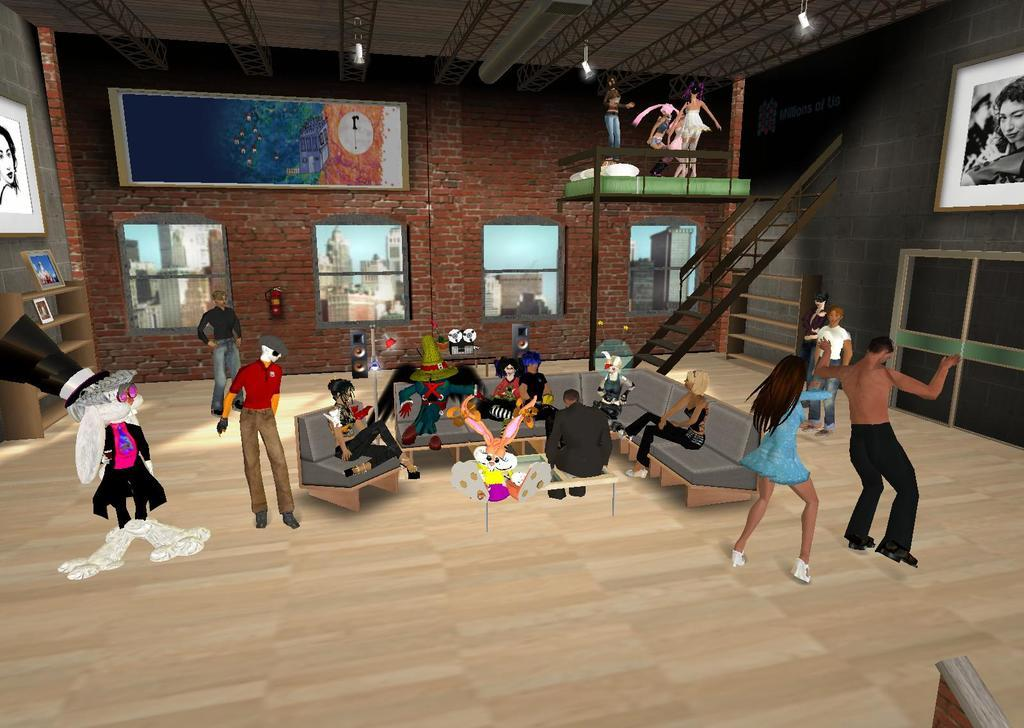What type of image is being described? The image is an animated image. What is happening in the animated image? There are people inside a house in the image. What type of pets can be seen in the house in the image? There are no pets visible in the image; it only shows people inside a house. What invention is being used by the people in the house in the image? There is no specific invention mentioned or visible in the image; it only shows people inside a house. 